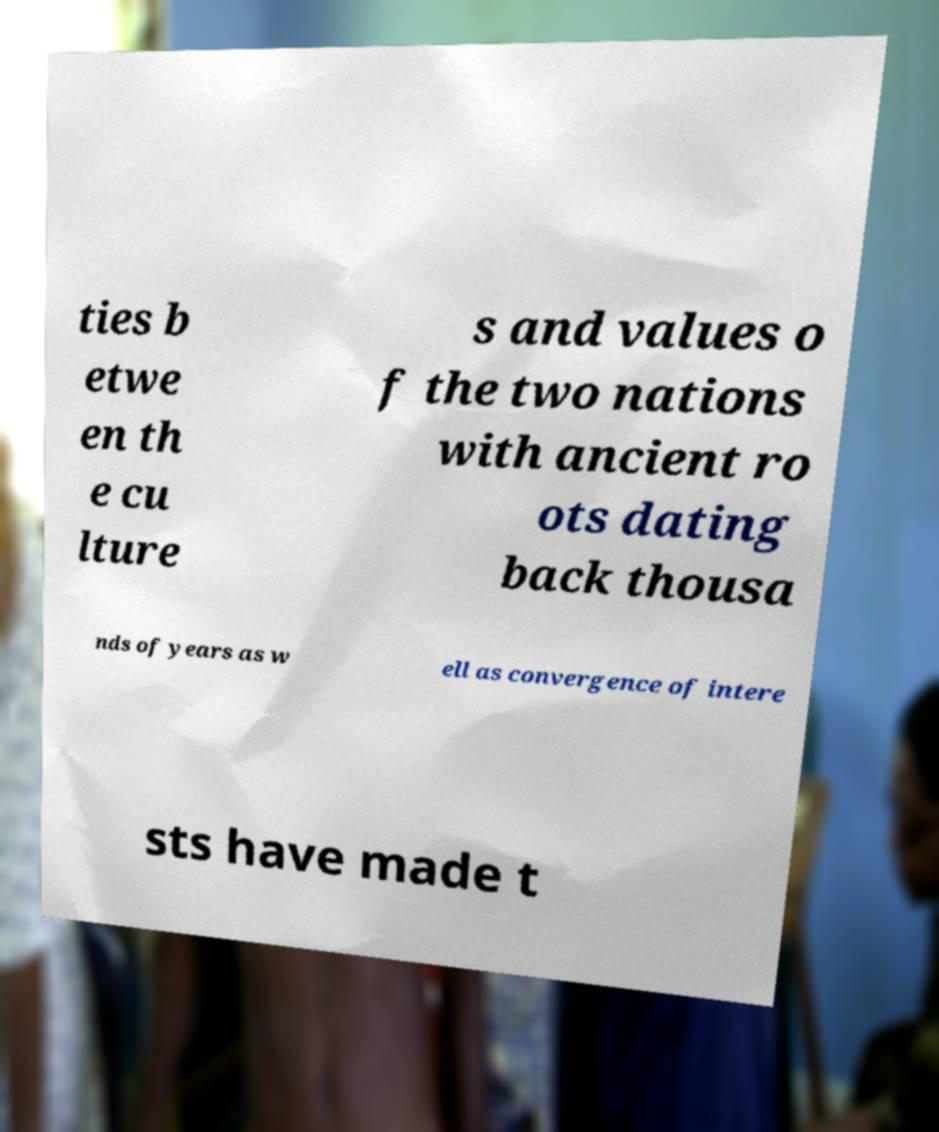Can you accurately transcribe the text from the provided image for me? ties b etwe en th e cu lture s and values o f the two nations with ancient ro ots dating back thousa nds of years as w ell as convergence of intere sts have made t 